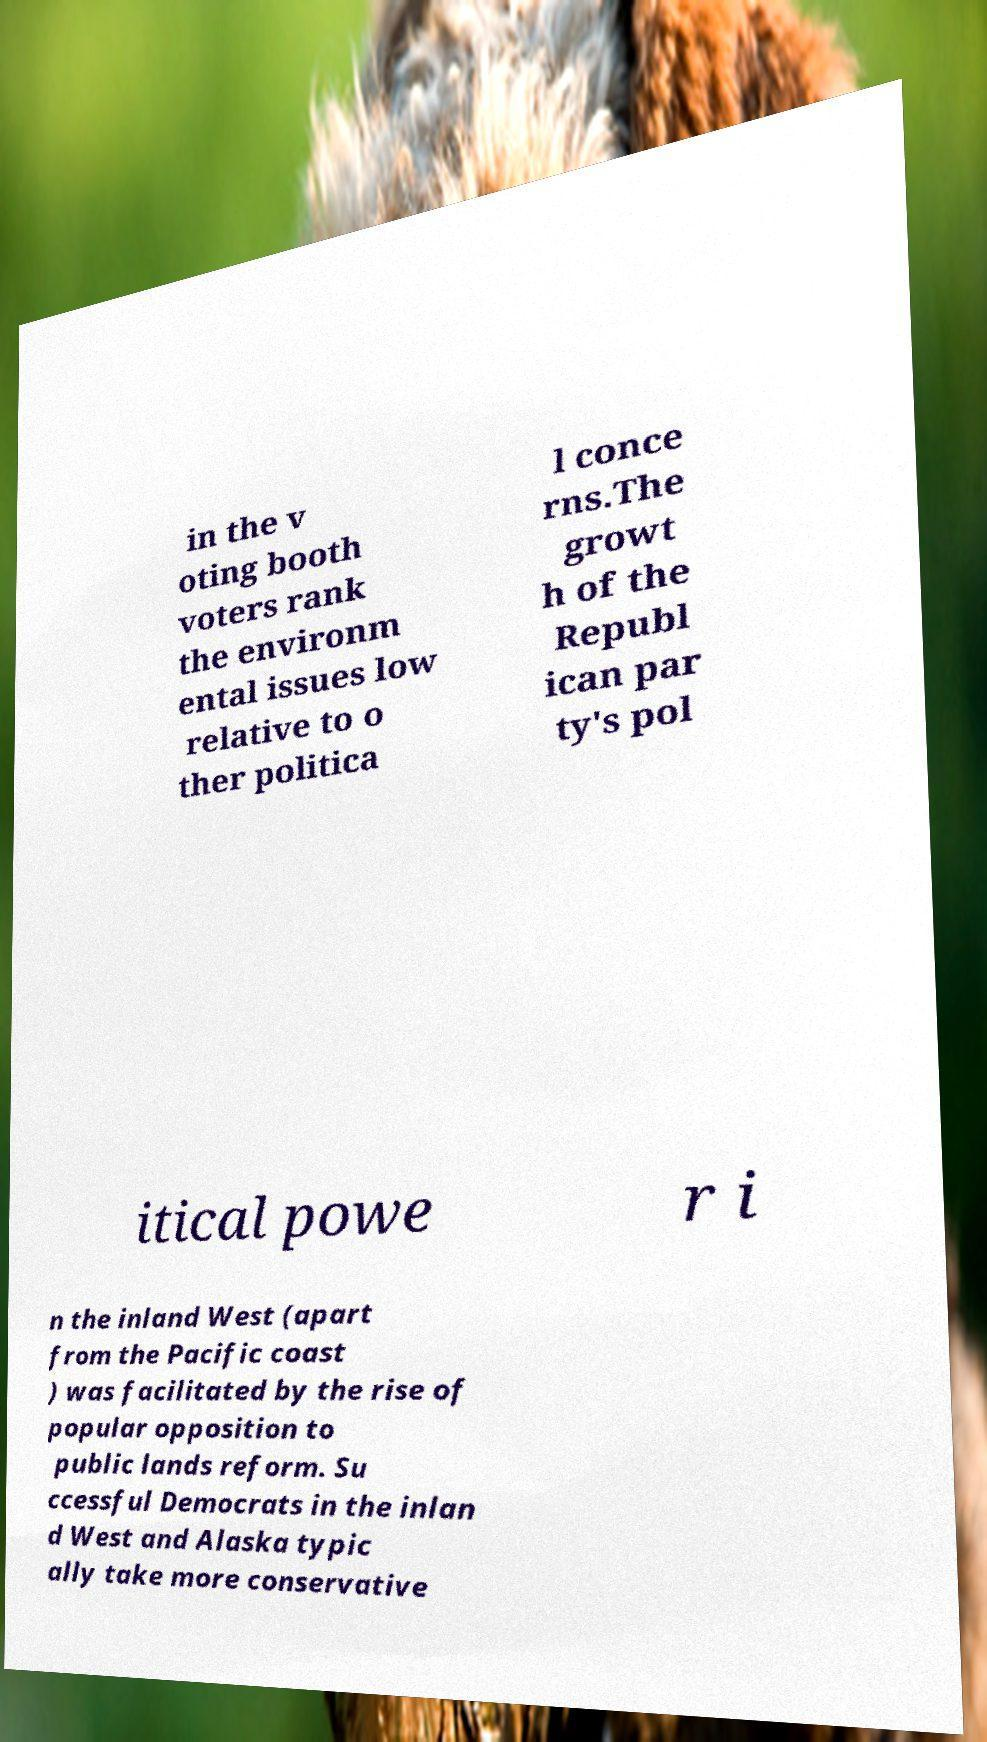For documentation purposes, I need the text within this image transcribed. Could you provide that? in the v oting booth voters rank the environm ental issues low relative to o ther politica l conce rns.The growt h of the Republ ican par ty's pol itical powe r i n the inland West (apart from the Pacific coast ) was facilitated by the rise of popular opposition to public lands reform. Su ccessful Democrats in the inlan d West and Alaska typic ally take more conservative 